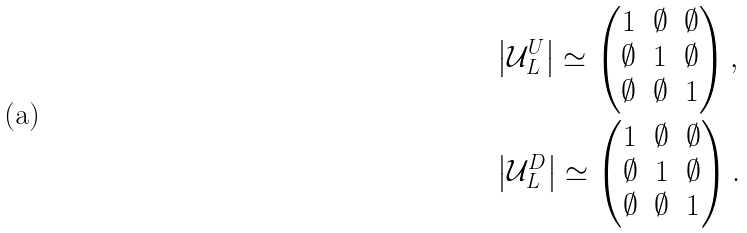Convert formula to latex. <formula><loc_0><loc_0><loc_500><loc_500>& \left | \mathcal { U } ^ { U } _ { L } \right | \simeq \begin{pmatrix} 1 & \emptyset & \emptyset \\ \emptyset & 1 & \emptyset \\ \emptyset & \emptyset & 1 \end{pmatrix} , \\ & \left | \mathcal { U } ^ { D } _ { L } \right | \simeq \begin{pmatrix} 1 & \emptyset & \emptyset \\ \emptyset & 1 & \emptyset \\ \emptyset & \emptyset & 1 \end{pmatrix} .</formula> 